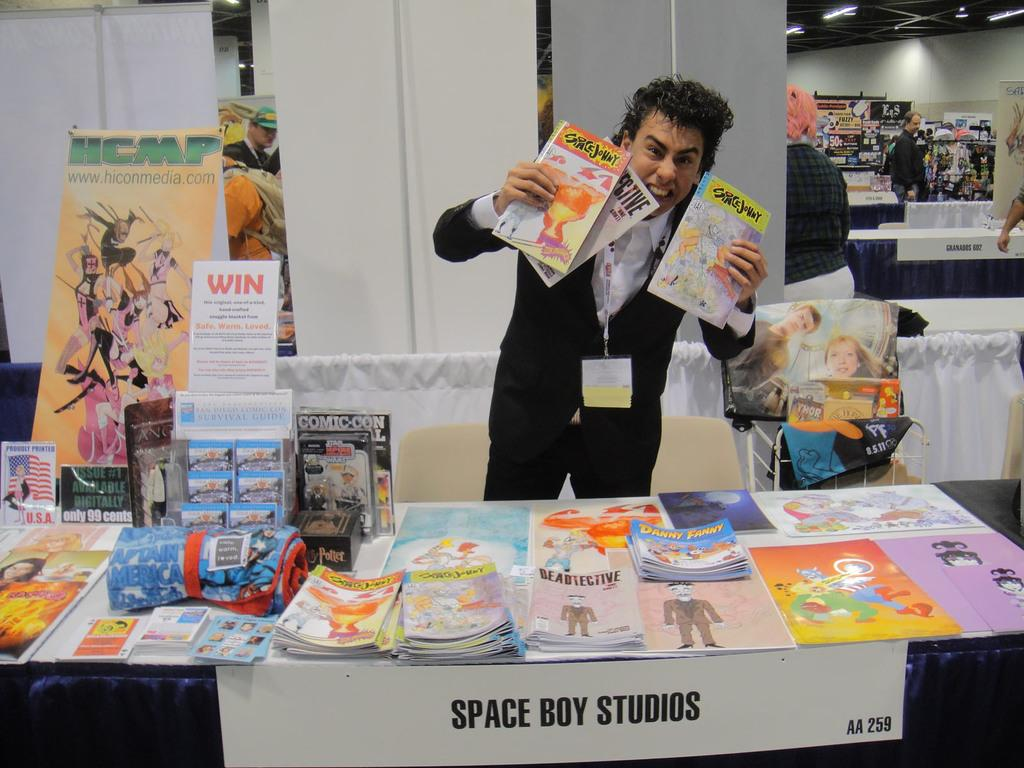<image>
Summarize the visual content of the image. A man holding up several drawings at a table with a "space boy studios" label on the bottom. 